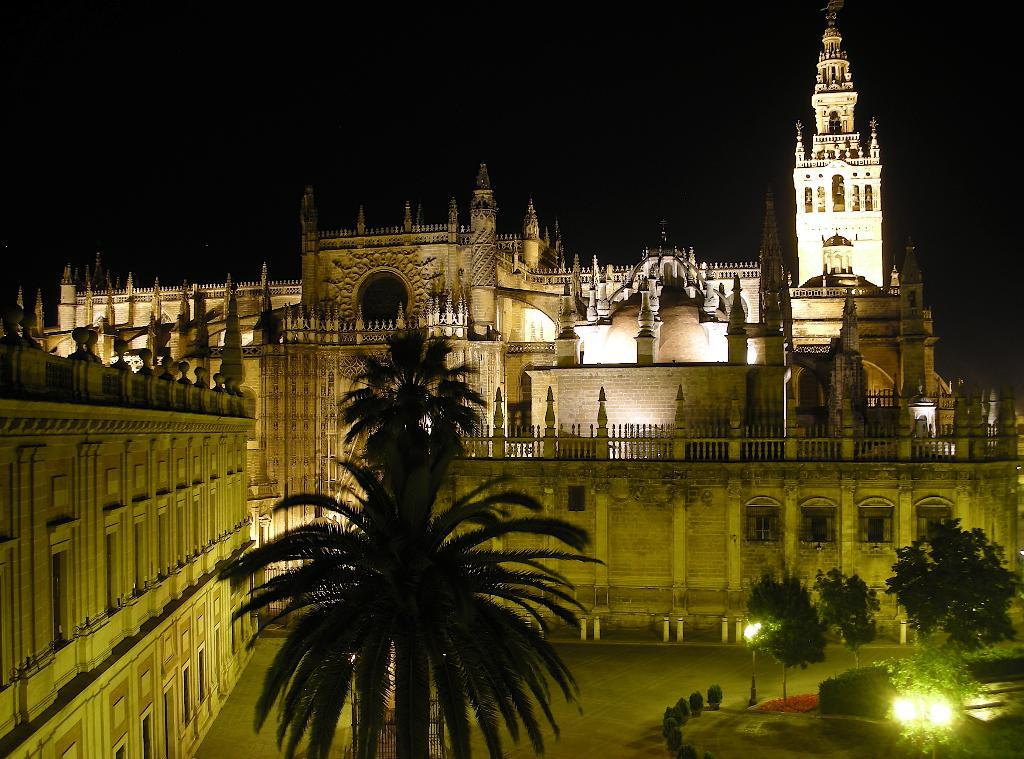What is the main feature of the image? There are many trees in the image. What else can be seen in the image besides trees? There are lights visible in the image, and there is a building with railing in the background. Can you describe the building in the background? The building has windows and a railing. What is the color of the background in the image? The background of the image is black. What type of road can be seen in the image? There is no road visible in the image; it primarily features trees and a building in the background. 